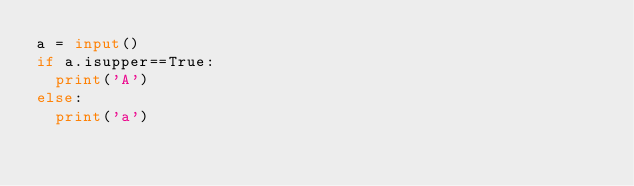<code> <loc_0><loc_0><loc_500><loc_500><_Python_>a = input()
if a.isupper==True:
  print('A')
else:
  print('a')
</code> 